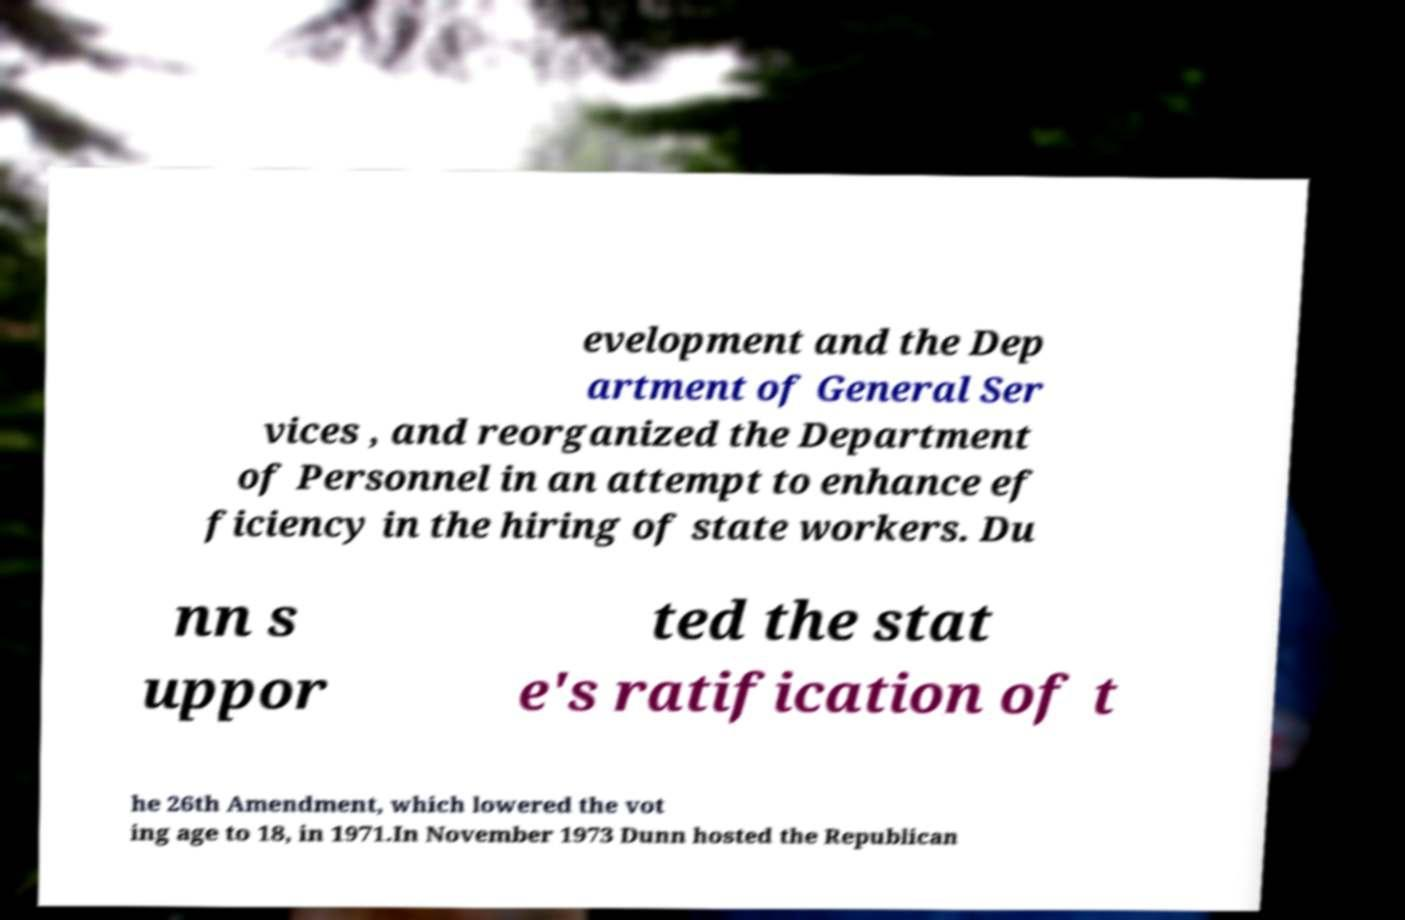Please read and relay the text visible in this image. What does it say? evelopment and the Dep artment of General Ser vices , and reorganized the Department of Personnel in an attempt to enhance ef ficiency in the hiring of state workers. Du nn s uppor ted the stat e's ratification of t he 26th Amendment, which lowered the vot ing age to 18, in 1971.In November 1973 Dunn hosted the Republican 